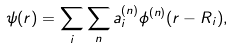Convert formula to latex. <formula><loc_0><loc_0><loc_500><loc_500>\psi ( { r } ) = \sum _ { i } \sum _ { n } a _ { i } ^ { ( n ) } \phi ^ { ( n ) } ( { r } - { R } _ { i } ) ,</formula> 